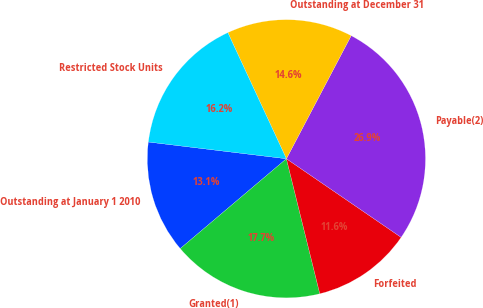Convert chart to OTSL. <chart><loc_0><loc_0><loc_500><loc_500><pie_chart><fcel>Outstanding at January 1 2010<fcel>Granted(1)<fcel>Forfeited<fcel>Payable(2)<fcel>Outstanding at December 31<fcel>Restricted Stock Units<nl><fcel>13.1%<fcel>17.68%<fcel>11.58%<fcel>26.85%<fcel>14.63%<fcel>16.16%<nl></chart> 